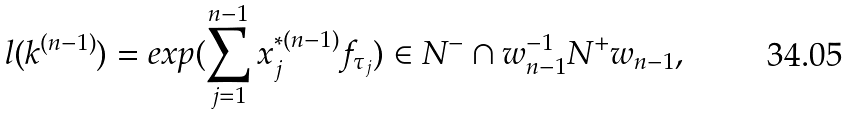<formula> <loc_0><loc_0><loc_500><loc_500>l ( k ^ { ( n - 1 ) } ) = e x p ( \sum _ { j = 1 } ^ { n - 1 } x _ { j } ^ { * ( n - 1 ) } f _ { \tau _ { j } } ) \in N ^ { - } \cap w _ { n - 1 } ^ { - 1 } N ^ { + } w _ { n - 1 } ,</formula> 